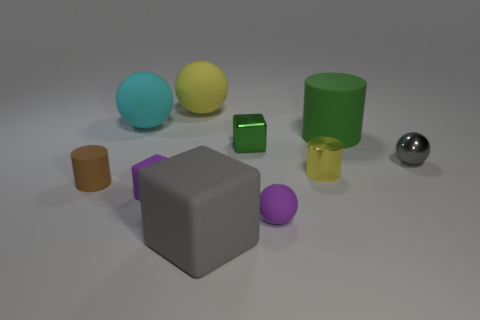Subtract all green cubes. How many cubes are left? 2 Subtract all gray spheres. How many spheres are left? 3 Subtract all cyan spheres. Subtract all green cylinders. How many spheres are left? 3 Subtract all cylinders. How many objects are left? 7 Add 7 yellow objects. How many yellow objects are left? 9 Add 9 yellow rubber balls. How many yellow rubber balls exist? 10 Subtract 0 gray cylinders. How many objects are left? 10 Subtract all brown things. Subtract all yellow blocks. How many objects are left? 9 